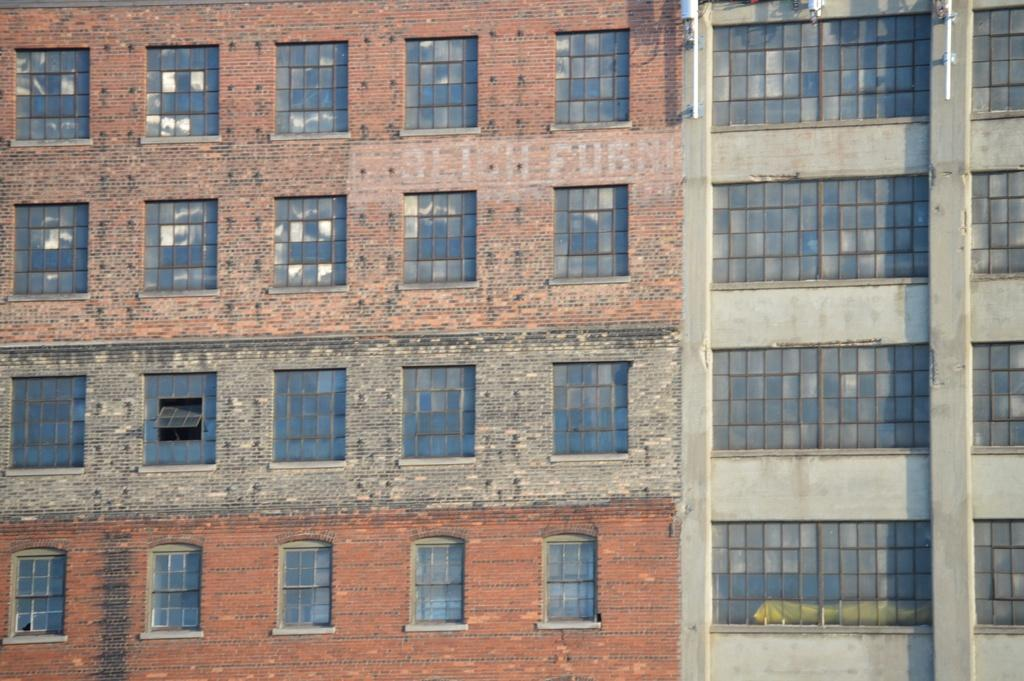What is located in the foreground of the image? There are windows in the foreground of the image. What type of structures do the windows belong to? The windows belong to buildings. What type of government is being discussed in the image? There is no discussion or indication of any government in the image; it only features windows and buildings. What type of agreement is being signed in the image? There is no agreement or indication of any signing event in the image; it only features windows and buildings. 